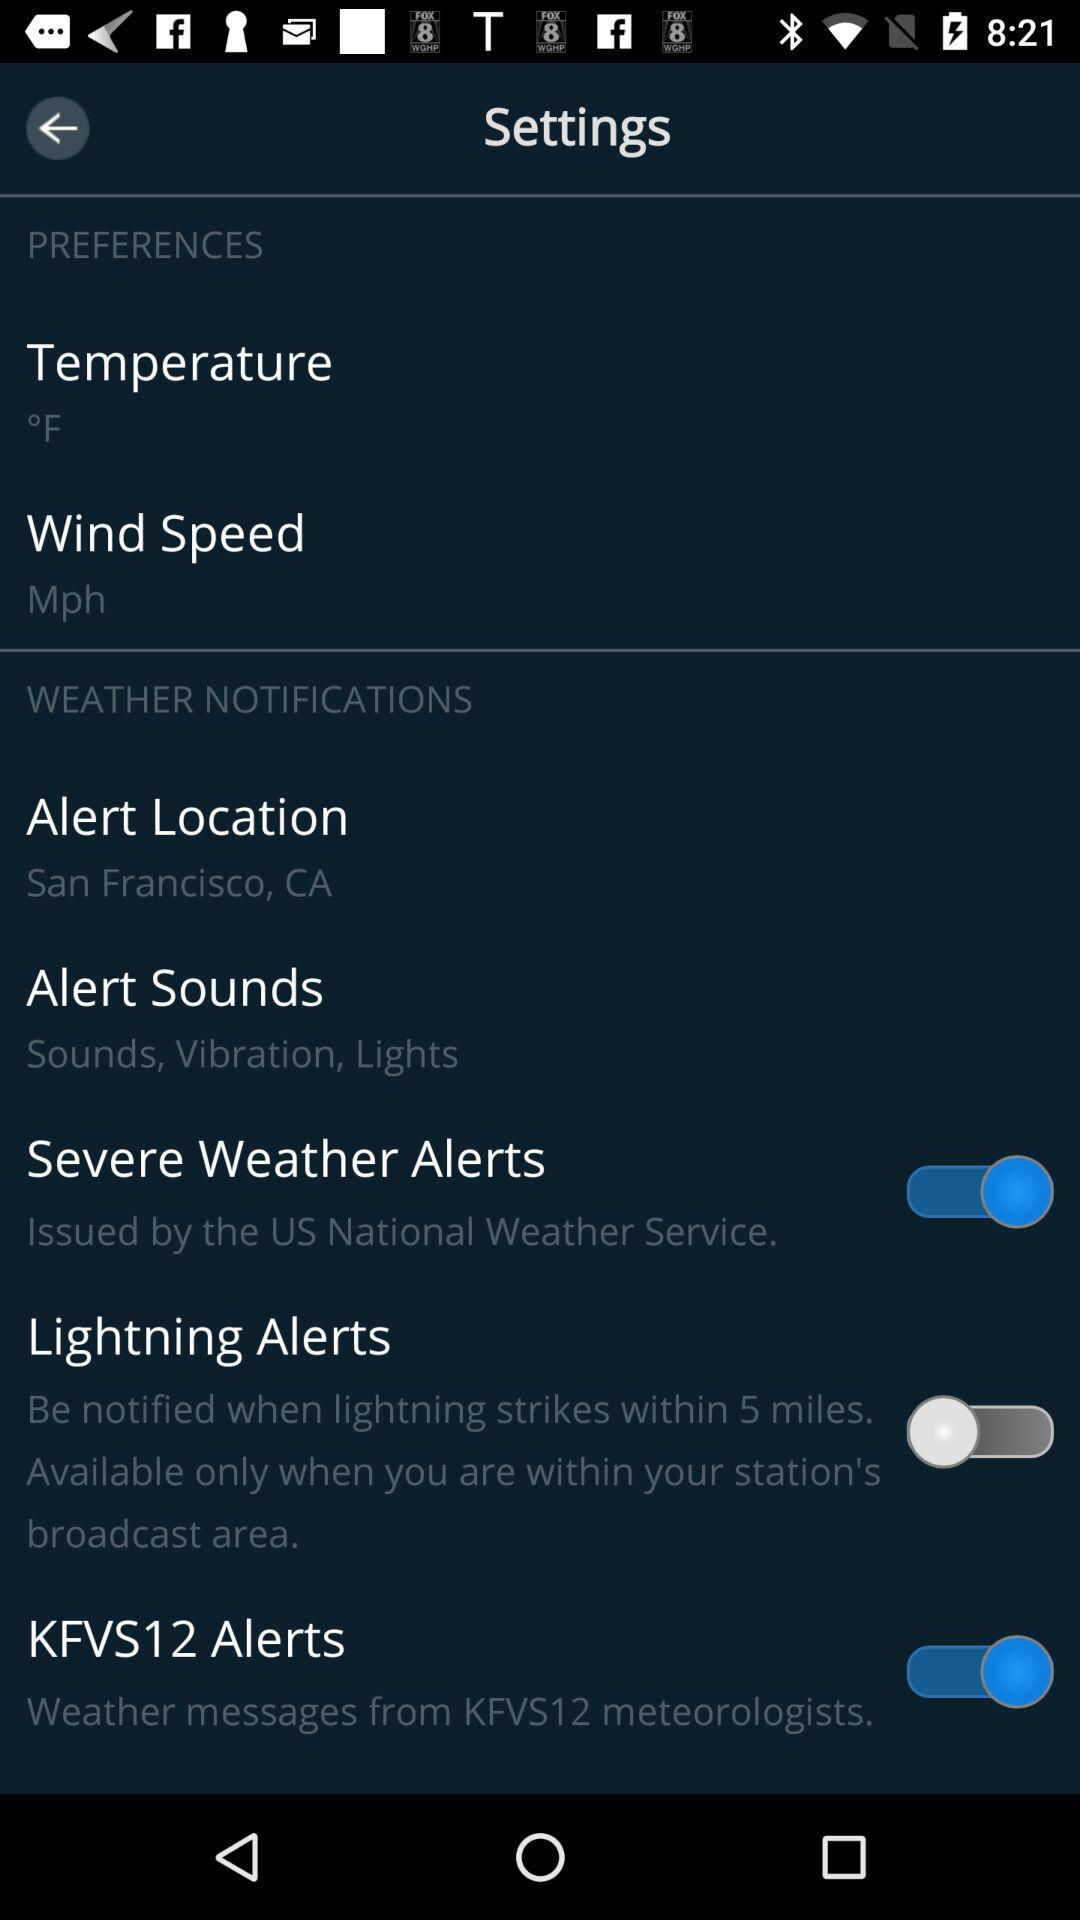What is the temperature? The temperature is °F. 